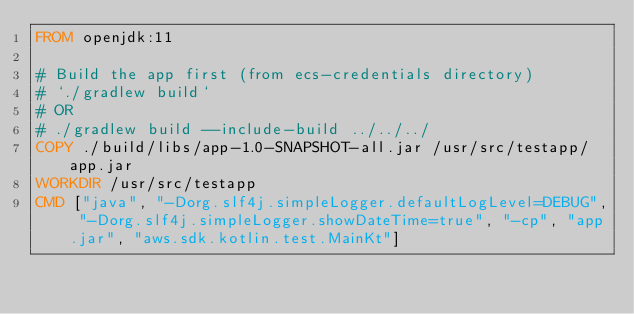Convert code to text. <code><loc_0><loc_0><loc_500><loc_500><_Dockerfile_>FROM openjdk:11

# Build the app first (from ecs-credentials directory)
# `./gradlew build`
# OR
# ./gradlew build --include-build ../../../
COPY ./build/libs/app-1.0-SNAPSHOT-all.jar /usr/src/testapp/app.jar
WORKDIR /usr/src/testapp
CMD ["java", "-Dorg.slf4j.simpleLogger.defaultLogLevel=DEBUG", "-Dorg.slf4j.simpleLogger.showDateTime=true", "-cp", "app.jar", "aws.sdk.kotlin.test.MainKt"]
</code> 